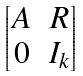<formula> <loc_0><loc_0><loc_500><loc_500>\begin{bmatrix} A & R \\ 0 & I _ { k } \end{bmatrix}</formula> 